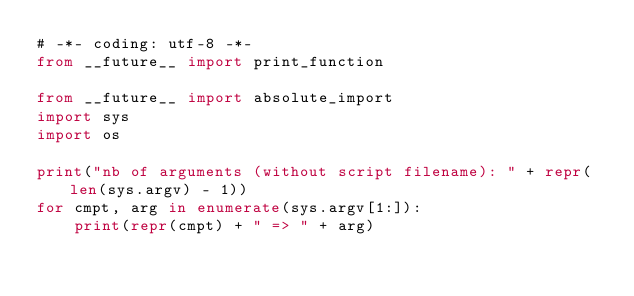<code> <loc_0><loc_0><loc_500><loc_500><_Python_># -*- coding: utf-8 -*-
from __future__ import print_function

from __future__ import absolute_import
import sys
import os

print("nb of arguments (without script filename): " + repr(len(sys.argv) - 1))
for cmpt, arg in enumerate(sys.argv[1:]):
    print(repr(cmpt) + " => " + arg)
</code> 